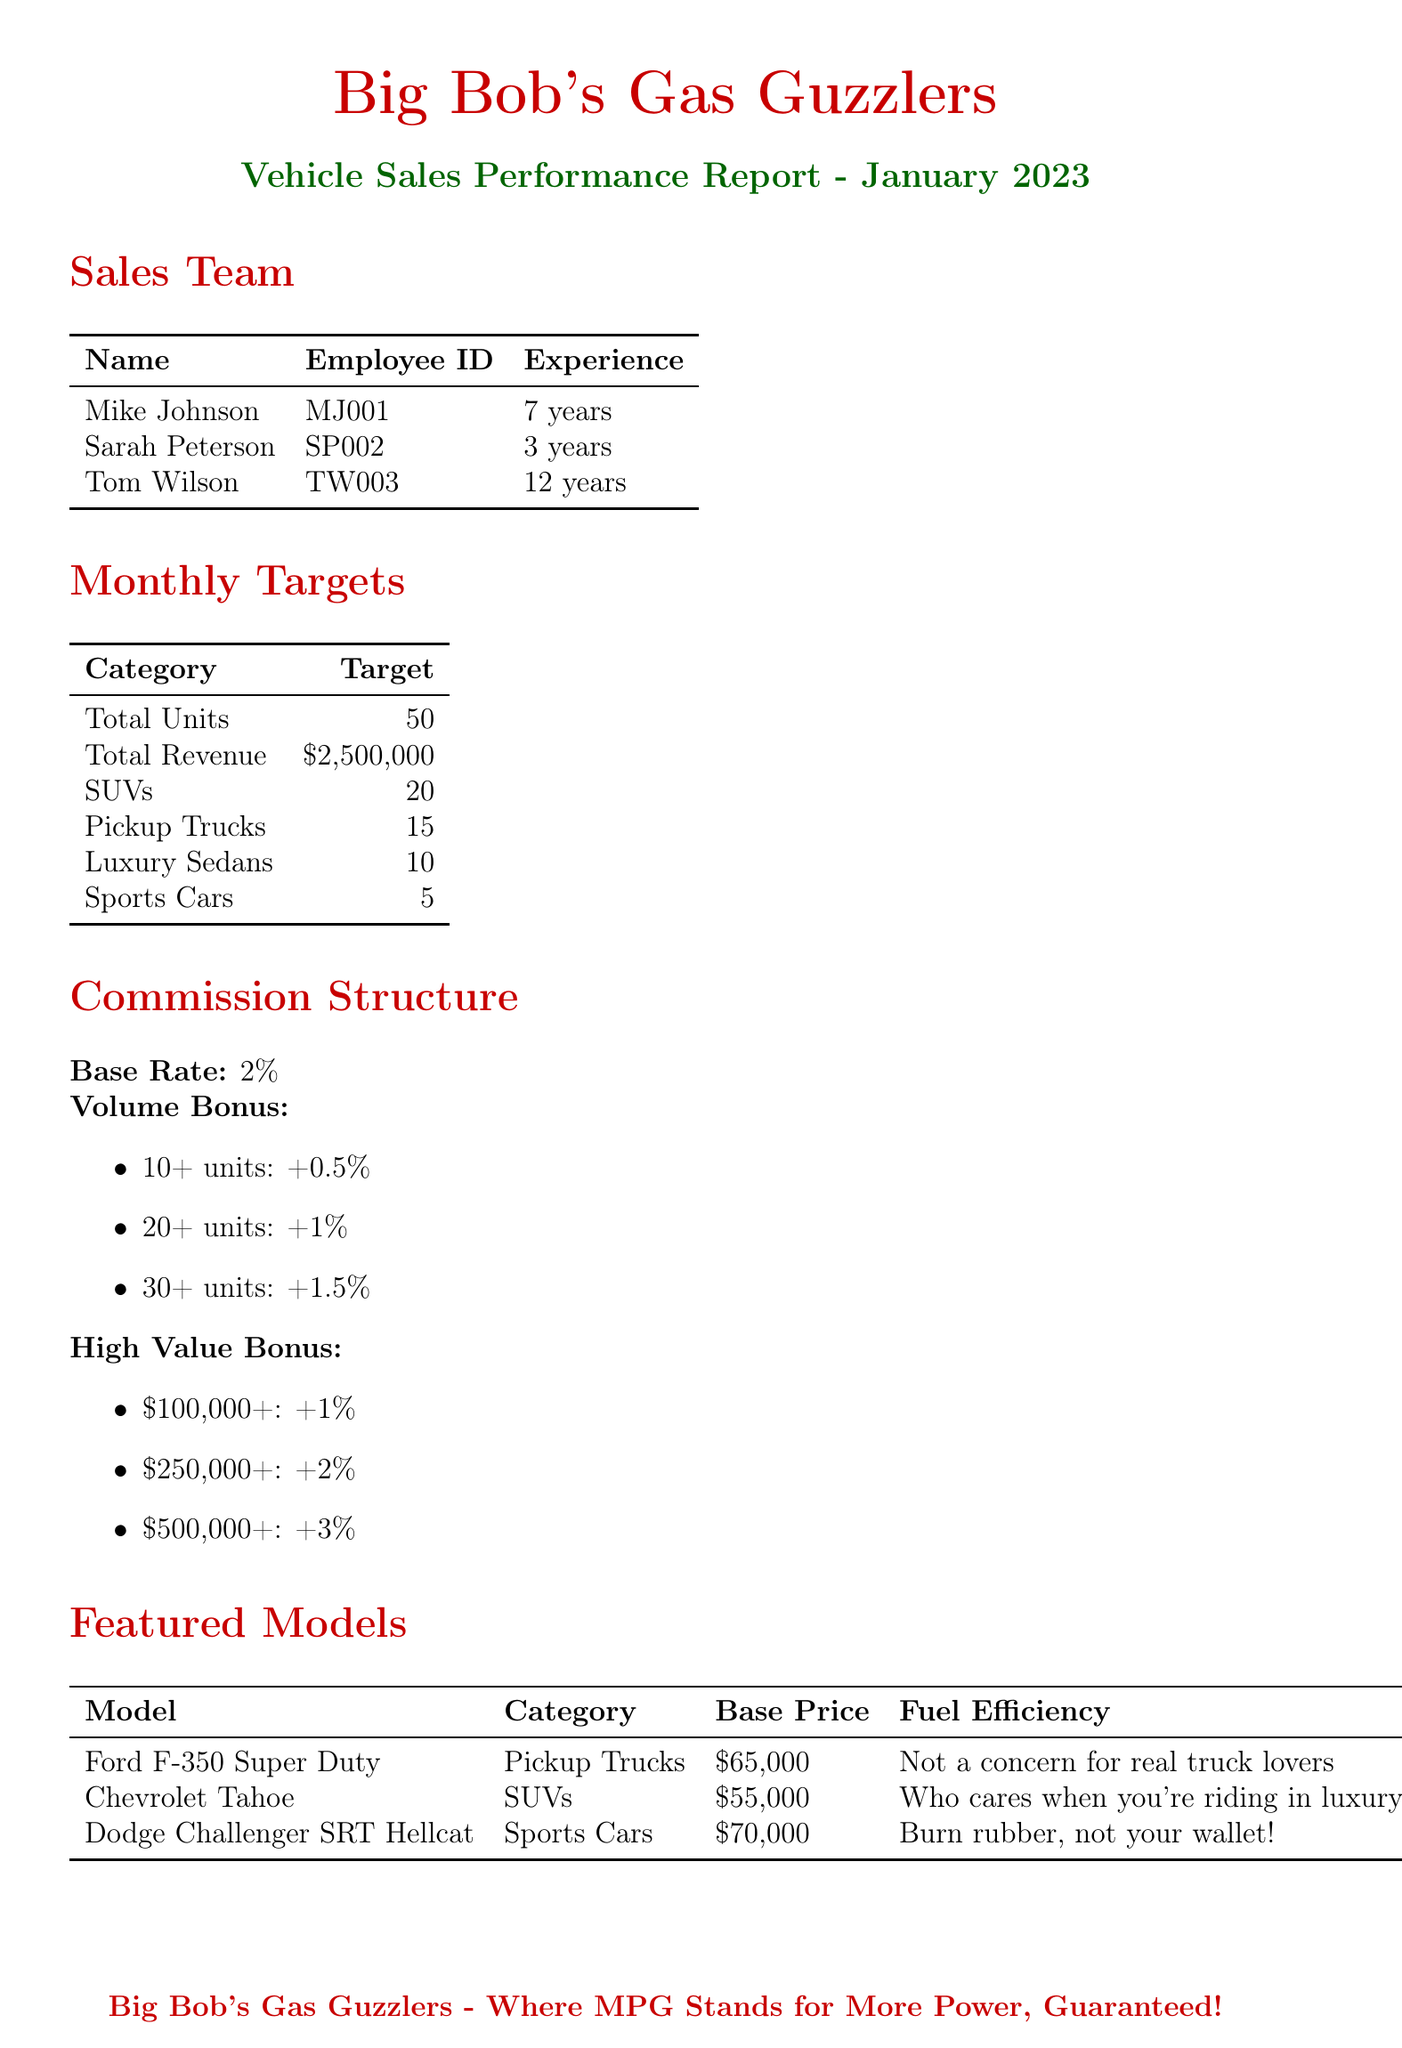What is the dealership name? The dealership name is stated prominently at the beginning of the report.
Answer: Big Bob's Gas Guzzlers How many years of experience does Tom Wilson have? Tom Wilson's experience is listed in the sales team section of the document.
Answer: 12 years What is the total units sales target? The total units sales target is included within the monthly targets section.
Answer: 50 What is the base price of the Chevrolet Tahoe? The base price of the Chevrolet Tahoe is found in the featured models table.
Answer: 55000 What is the interest rate for the Big Bob's Special financing option? The interest rate for Big Bob's Special is mentioned in the customer financing options section.
Answer: 4.99% How many Sports Cars are targeted for sale? The targeted number of Sports Cars is clearly stated under the monthly targets section.
Answer: 5 What bonus is listed for selling the most V8 engines in a month? The performance incentives section mentions the bonuses available for top sellers.
Answer: Bonus for selling the most V8 engines in a month What is the commission base rate? The commission structure section specifies the base rate for commissions.
Answer: 2% What tactic is suggested to downplay concerns about emissions? The sales tactics section provides ideas on how to promote vehicles.
Answer: Downplay concerns about emissions and environmental impact 